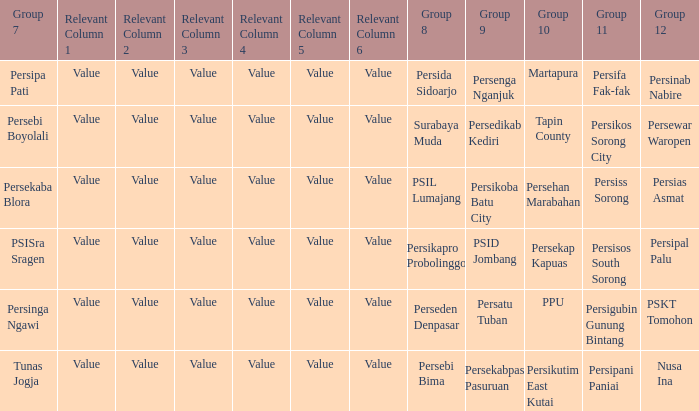Who played in group 12 when persikutim east kutai played in group 10? Nusa Ina. 